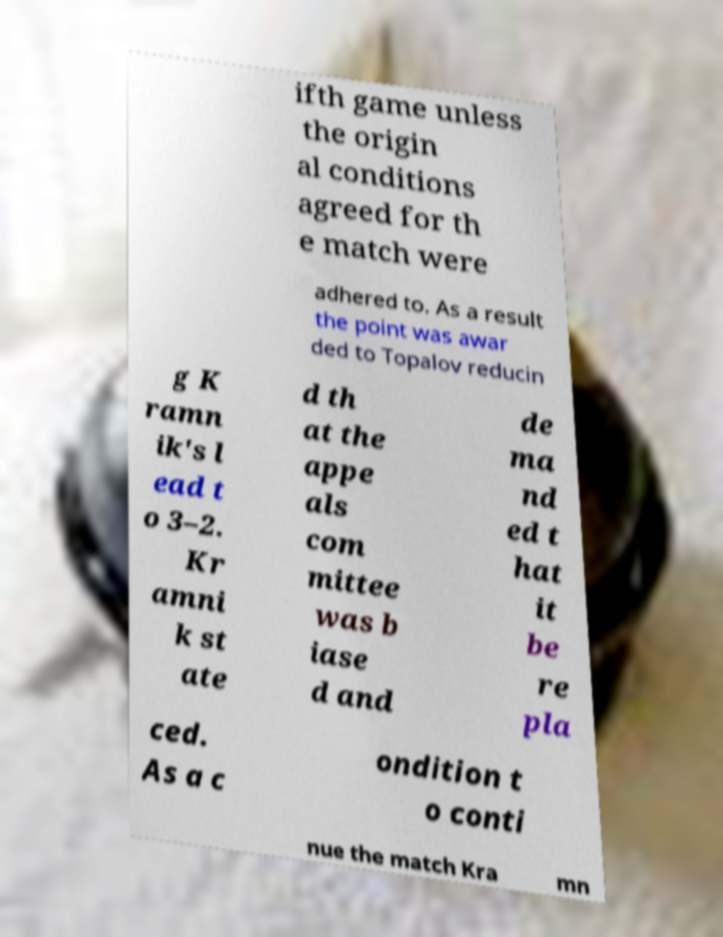Please read and relay the text visible in this image. What does it say? ifth game unless the origin al conditions agreed for th e match were adhered to. As a result the point was awar ded to Topalov reducin g K ramn ik's l ead t o 3–2. Kr amni k st ate d th at the appe als com mittee was b iase d and de ma nd ed t hat it be re pla ced. As a c ondition t o conti nue the match Kra mn 